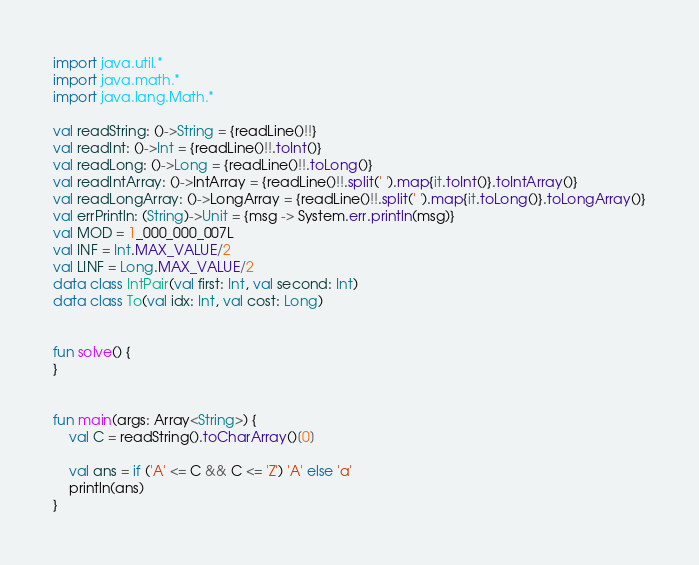Convert code to text. <code><loc_0><loc_0><loc_500><loc_500><_Kotlin_>import java.util.*
import java.math.*
import java.lang.Math.*

val readString: ()->String = {readLine()!!}
val readInt: ()->Int = {readLine()!!.toInt()}
val readLong: ()->Long = {readLine()!!.toLong()}
val readIntArray: ()->IntArray = {readLine()!!.split(' ').map{it.toInt()}.toIntArray()}
val readLongArray: ()->LongArray = {readLine()!!.split(' ').map{it.toLong()}.toLongArray()}
val errPrintln: (String)->Unit = {msg -> System.err.println(msg)}
val MOD = 1_000_000_007L
val INF = Int.MAX_VALUE/2
val LINF = Long.MAX_VALUE/2
data class IntPair(val first: Int, val second: Int)
data class To(val idx: Int, val cost: Long)


fun solve() {
}


fun main(args: Array<String>) {
    val C = readString().toCharArray()[0]

    val ans = if ('A' <= C && C <= 'Z') 'A' else 'a'
    println(ans)
}
</code> 